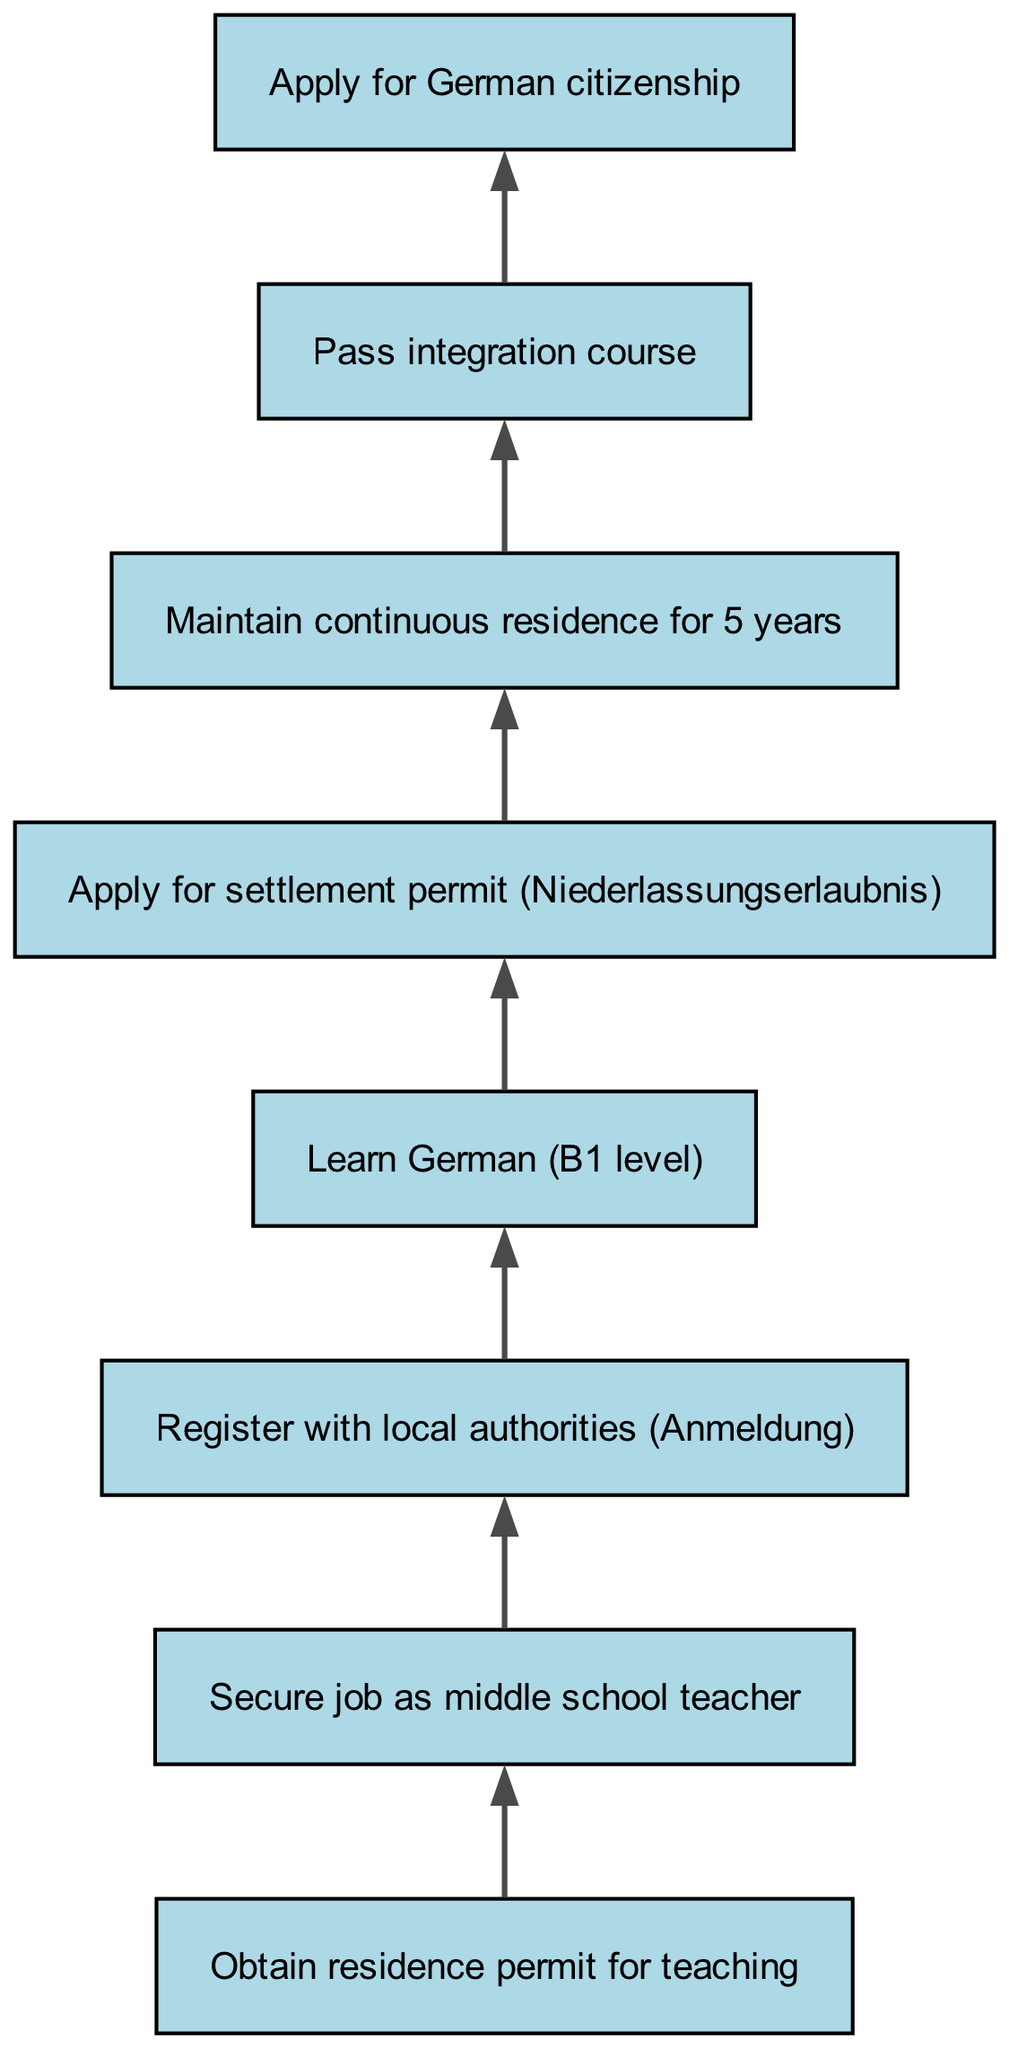What is the first step in obtaining permanent residency in Germany? The first step in the flow chart is to "Obtain residence permit for teaching," which is positioned at the bottom of the chart and indicates the starting point of the process.
Answer: Obtain residence permit for teaching How many nodes are present in the diagram? The diagram contains a total of 8 nodes that represent different steps in the process of obtaining permanent residency in Germany.
Answer: 8 What is the last step before applying for German citizenship? The last step before applying for German citizenship is to "Pass integration course," which connects directly to the application for citizenship, giving it significance as a prerequisite.
Answer: Pass integration course What must be learned to progress from registration to applying for a settlement permit? To progress from "Register with local authorities (Anmeldung)" to "Apply for settlement permit (Niederlassungserlaubnis)," it is necessary to "Learn German (B1 level)," which acts as a key requirement for this transition.
Answer: Learn German (B1 level) How many years of continuous residence is required before applying for citizenship? The process requires maintaining continuous residence for 5 years, which is depicted in the diagram as a necessary condition prior to being eligible for citizenship application.
Answer: 5 years Which step follows maintaining continuous residence? After maintaining continuous residence for 5 years, the next step in the diagram is to "Pass integration course," indicating that this is a subsequent requirement to further the residency process.
Answer: Pass integration course What is the relationship between securing a job as a middle school teacher and registering with local authorities? The relationship is sequential: after securing a job as a middle school teacher, the next step in the flow is to "Register with local authorities (Anmeldung)," showing that registration is dependent on having achieved employment.
Answer: Sequential relationship What is necessary to apply for a settlement permit after learning German? After learning German at the B1 level, the next necessary step is to "Apply for settlement permit (Niederlassungserlaubnis)," showing the direct linkage between language proficiency and applying for permanent residency.
Answer: Apply for settlement permit (Niederlassungserlaubnis) 